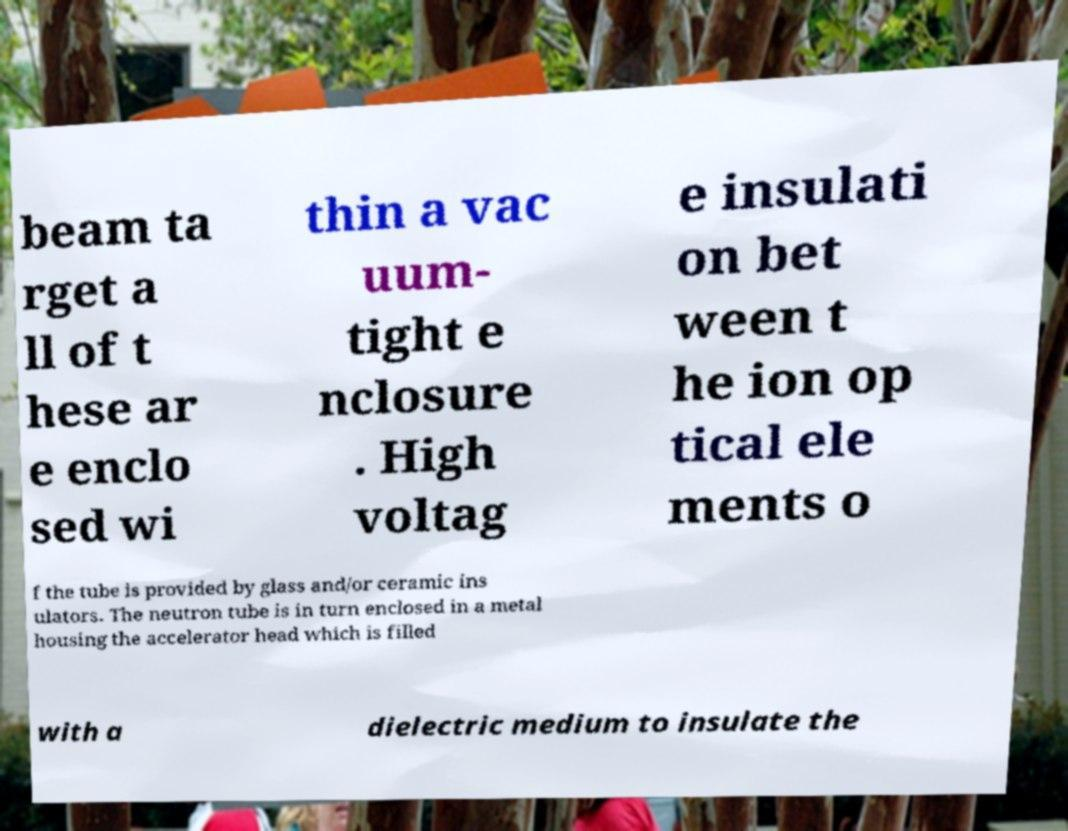Can you accurately transcribe the text from the provided image for me? beam ta rget a ll of t hese ar e enclo sed wi thin a vac uum- tight e nclosure . High voltag e insulati on bet ween t he ion op tical ele ments o f the tube is provided by glass and/or ceramic ins ulators. The neutron tube is in turn enclosed in a metal housing the accelerator head which is filled with a dielectric medium to insulate the 